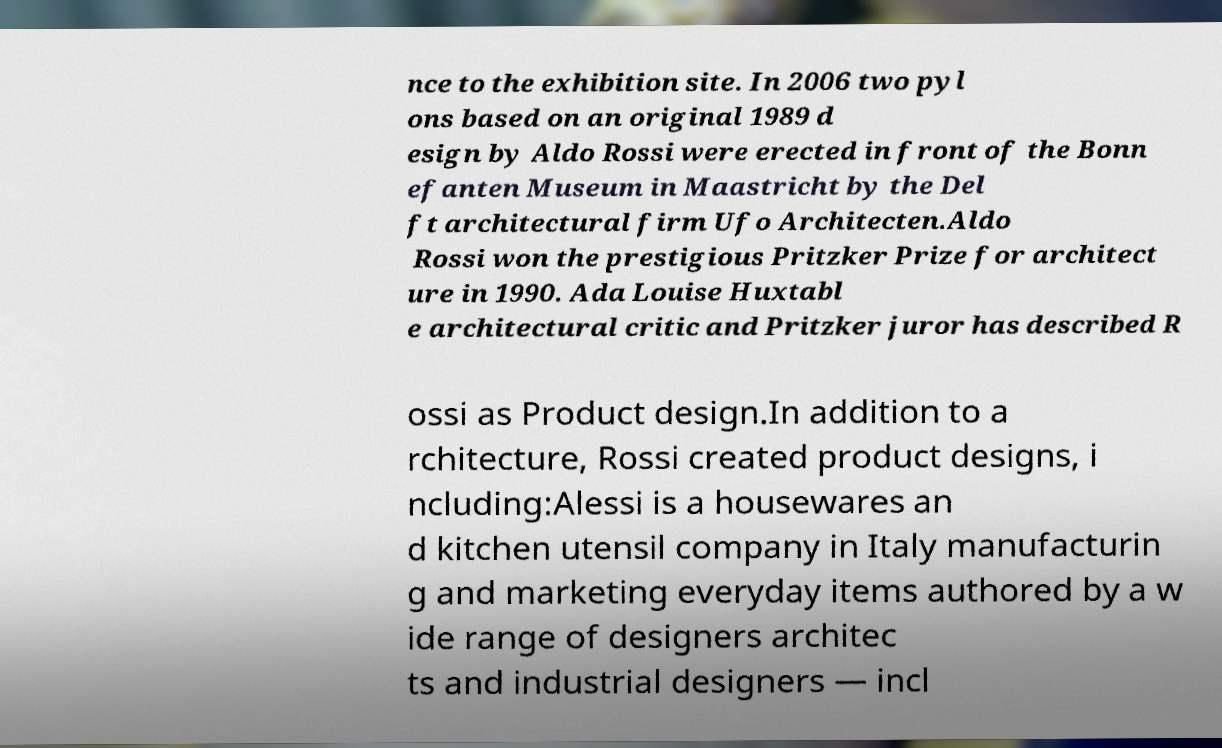Please identify and transcribe the text found in this image. nce to the exhibition site. In 2006 two pyl ons based on an original 1989 d esign by Aldo Rossi were erected in front of the Bonn efanten Museum in Maastricht by the Del ft architectural firm Ufo Architecten.Aldo Rossi won the prestigious Pritzker Prize for architect ure in 1990. Ada Louise Huxtabl e architectural critic and Pritzker juror has described R ossi as Product design.In addition to a rchitecture, Rossi created product designs, i ncluding:Alessi is a housewares an d kitchen utensil company in Italy manufacturin g and marketing everyday items authored by a w ide range of designers architec ts and industrial designers — incl 